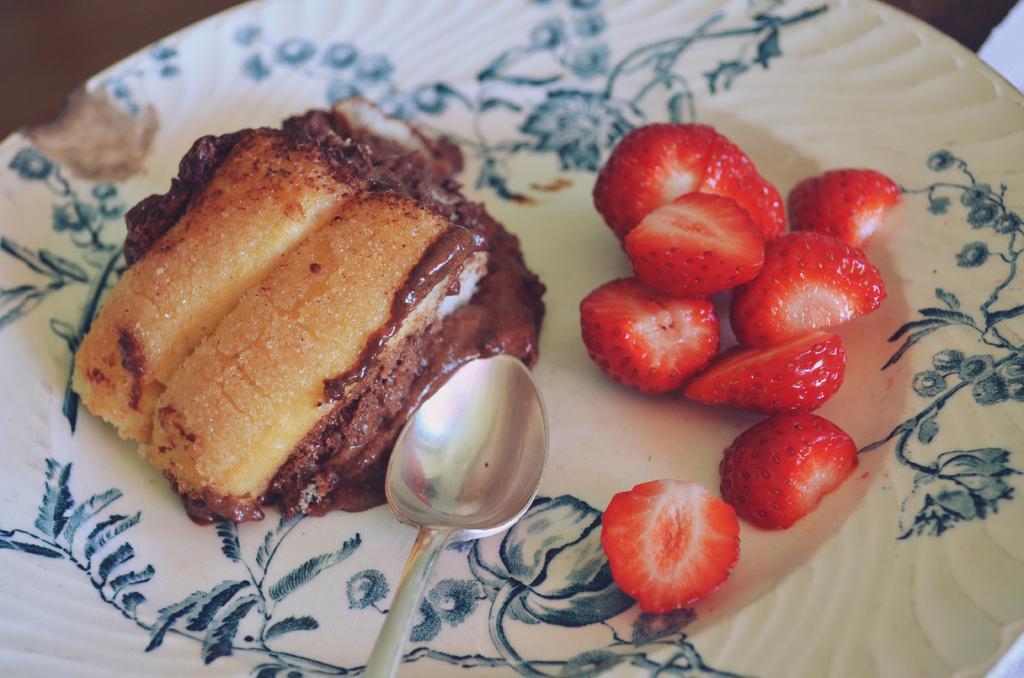Can you describe this image briefly? In the picture we can see a plate with a food item in it beside it we can see some slices of strawberries and a spoon. 